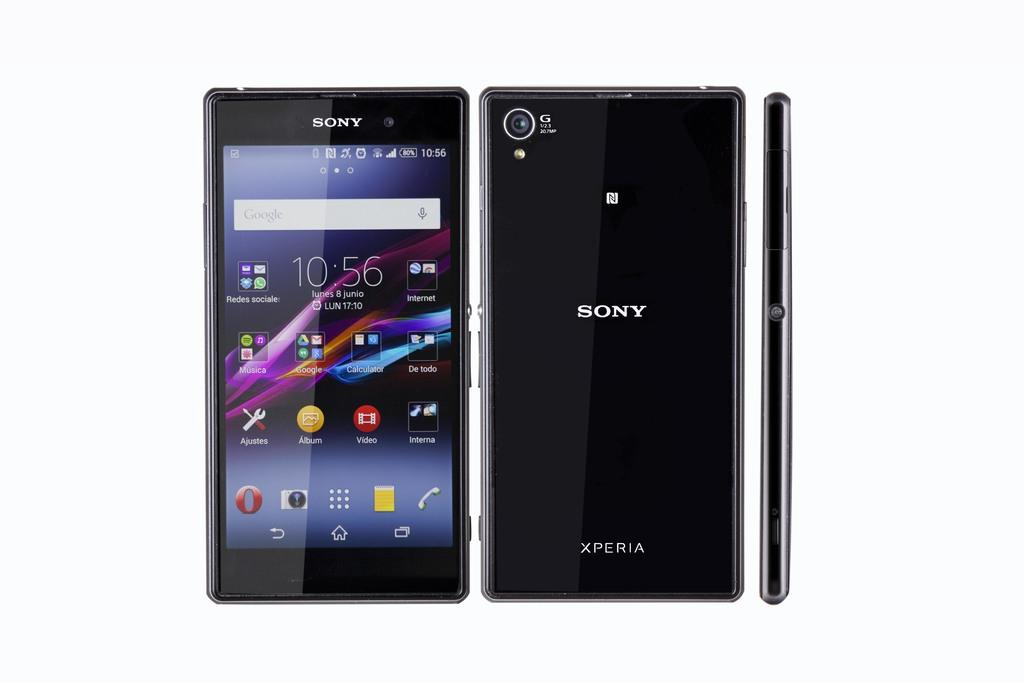<image>
Render a clear and concise summary of the photo. The time on the Sony cellphone says 10:56. 